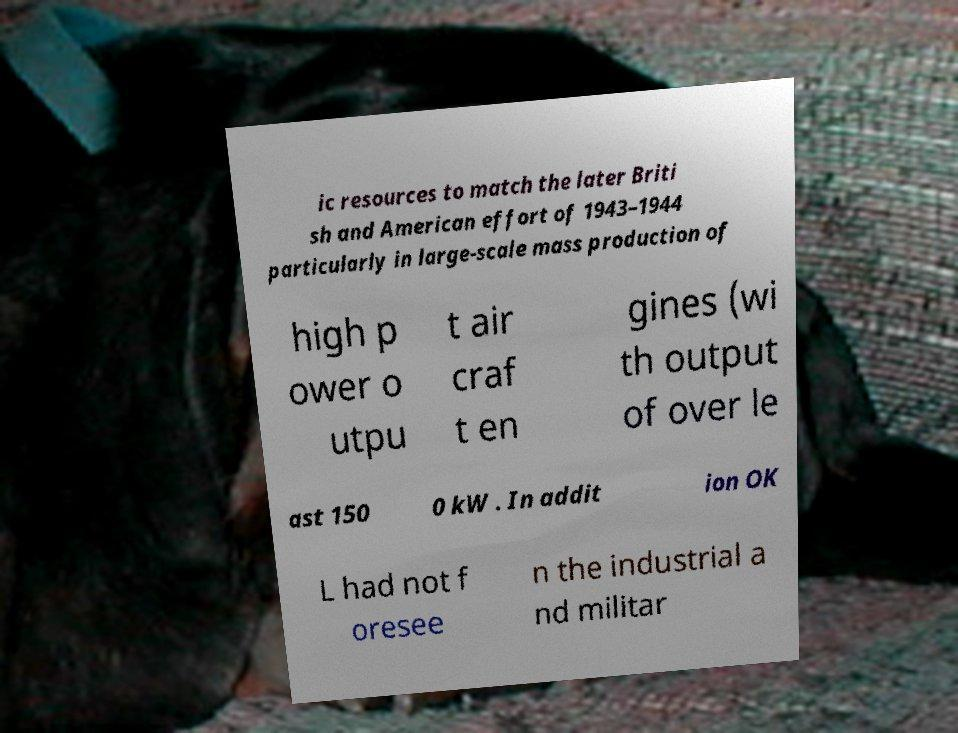For documentation purposes, I need the text within this image transcribed. Could you provide that? ic resources to match the later Briti sh and American effort of 1943–1944 particularly in large-scale mass production of high p ower o utpu t air craf t en gines (wi th output of over le ast 150 0 kW . In addit ion OK L had not f oresee n the industrial a nd militar 